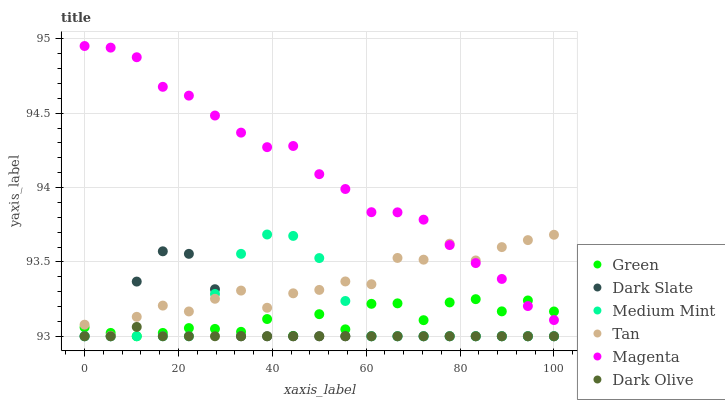Does Dark Olive have the minimum area under the curve?
Answer yes or no. Yes. Does Magenta have the maximum area under the curve?
Answer yes or no. Yes. Does Dark Slate have the minimum area under the curve?
Answer yes or no. No. Does Dark Slate have the maximum area under the curve?
Answer yes or no. No. Is Dark Olive the smoothest?
Answer yes or no. Yes. Is Green the roughest?
Answer yes or no. Yes. Is Dark Slate the smoothest?
Answer yes or no. No. Is Dark Slate the roughest?
Answer yes or no. No. Does Medium Mint have the lowest value?
Answer yes or no. Yes. Does Tan have the lowest value?
Answer yes or no. No. Does Magenta have the highest value?
Answer yes or no. Yes. Does Dark Slate have the highest value?
Answer yes or no. No. Is Dark Olive less than Magenta?
Answer yes or no. Yes. Is Magenta greater than Dark Olive?
Answer yes or no. Yes. Does Dark Slate intersect Dark Olive?
Answer yes or no. Yes. Is Dark Slate less than Dark Olive?
Answer yes or no. No. Is Dark Slate greater than Dark Olive?
Answer yes or no. No. Does Dark Olive intersect Magenta?
Answer yes or no. No. 